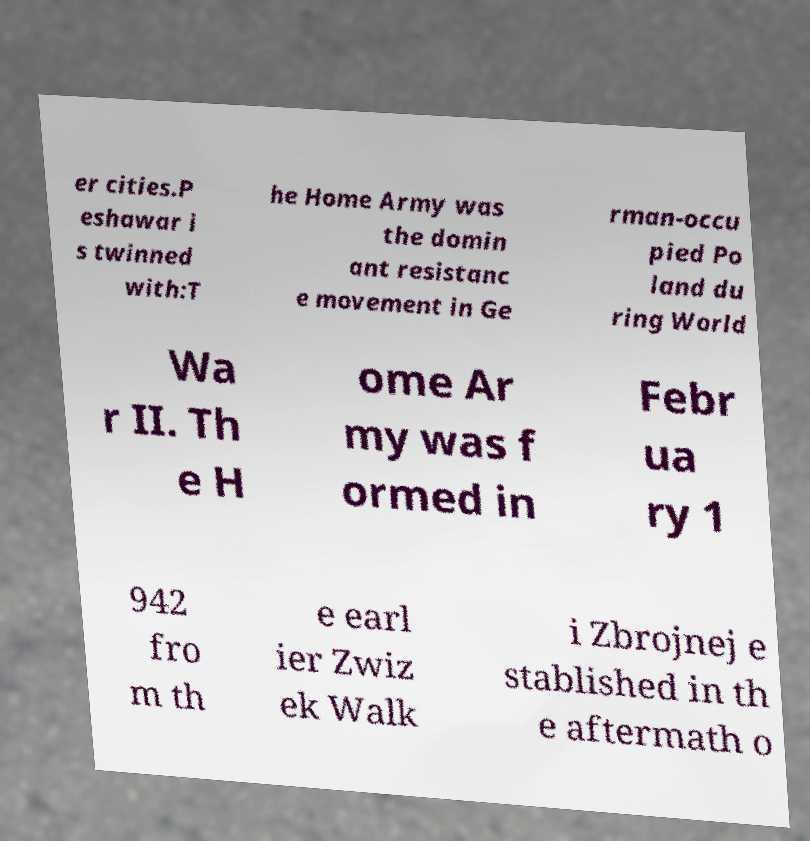Could you assist in decoding the text presented in this image and type it out clearly? er cities.P eshawar i s twinned with:T he Home Army was the domin ant resistanc e movement in Ge rman-occu pied Po land du ring World Wa r II. Th e H ome Ar my was f ormed in Febr ua ry 1 942 fro m th e earl ier Zwiz ek Walk i Zbrojnej e stablished in th e aftermath o 